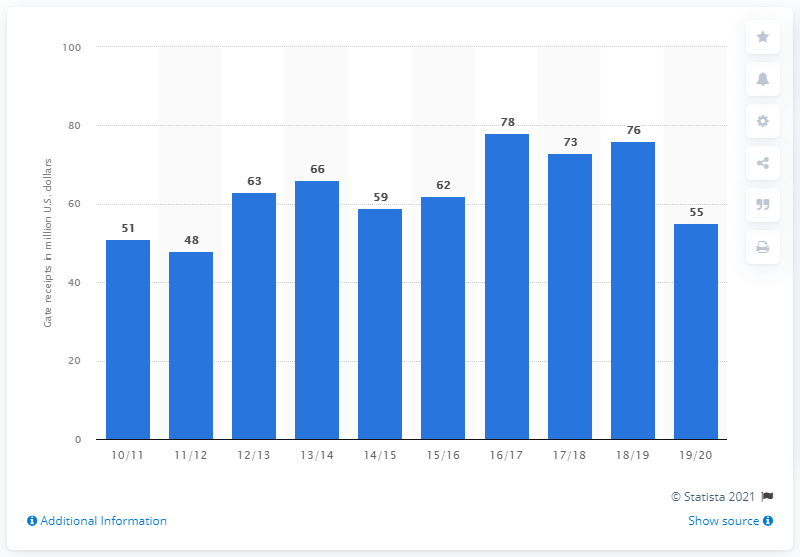Identify some key points in this picture. The gate receipts for the San Antonio Spurs in the 2019/20 season were $55. In 19/20, there was a year that had 55 million dollars. The sum of receipts above 70 million U.S dollars is 227. 